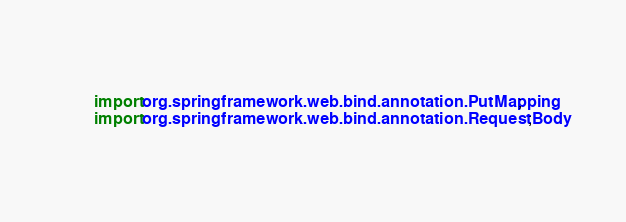<code> <loc_0><loc_0><loc_500><loc_500><_Java_>import org.springframework.web.bind.annotation.PutMapping;
import org.springframework.web.bind.annotation.RequestBody;</code> 